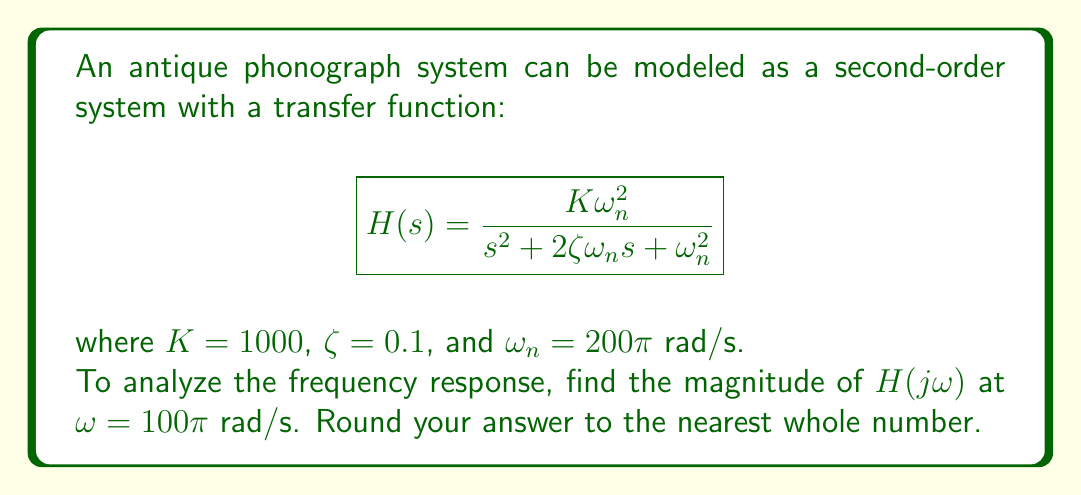Show me your answer to this math problem. To find the magnitude of $H(j\omega)$ at $\omega = 100\pi$ rad/s, we follow these steps:

1) Substitute $s = j\omega$ into the transfer function:

   $$H(j\omega) = \frac{K\omega_n^2}{(j\omega)^2 + 2\zeta\omega_n (j\omega) + \omega_n^2}$$

2) Substitute the given values:

   $$H(j\omega) = \frac{1000(200\pi)^2}{(j\omega)^2 + 2(0.1)(200\pi)(j\omega) + (200\pi)^2}$$

3) Evaluate at $\omega = 100\pi$:

   $$H(j100\pi) = \frac{1000(200\pi)^2}{(j100\pi)^2 + 2(0.1)(200\pi)(j100\pi) + (200\pi)^2}$$

4) Simplify:

   $$H(j100\pi) = \frac{40000000\pi^2}{-10000\pi^2 + j4000\pi^2 + 40000\pi^2}$$
   
   $$= \frac{40000000\pi^2}{30000\pi^2 + j4000\pi^2}$$

5) To find the magnitude, we use:

   $$|H(j100\pi)| = \frac{|40000000\pi^2|}{\sqrt{(30000\pi^2)^2 + (4000\pi^2)^2}}$$

6) Calculate:

   $$|H(j100\pi)| = \frac{40000000\pi^2}{\pi^2\sqrt{30000^2 + 4000^2}} \approx 1324.1$$

7) Rounding to the nearest whole number:

   $$|H(j100\pi)| \approx 1324$$
Answer: 1324 